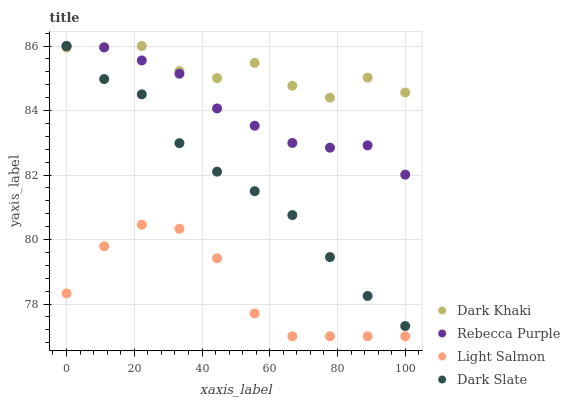Does Light Salmon have the minimum area under the curve?
Answer yes or no. Yes. Does Dark Khaki have the maximum area under the curve?
Answer yes or no. Yes. Does Dark Slate have the minimum area under the curve?
Answer yes or no. No. Does Dark Slate have the maximum area under the curve?
Answer yes or no. No. Is Rebecca Purple the smoothest?
Answer yes or no. Yes. Is Dark Khaki the roughest?
Answer yes or no. Yes. Is Dark Slate the smoothest?
Answer yes or no. No. Is Dark Slate the roughest?
Answer yes or no. No. Does Light Salmon have the lowest value?
Answer yes or no. Yes. Does Dark Slate have the lowest value?
Answer yes or no. No. Does Rebecca Purple have the highest value?
Answer yes or no. Yes. Does Light Salmon have the highest value?
Answer yes or no. No. Is Light Salmon less than Dark Khaki?
Answer yes or no. Yes. Is Dark Slate greater than Light Salmon?
Answer yes or no. Yes. Does Rebecca Purple intersect Dark Khaki?
Answer yes or no. Yes. Is Rebecca Purple less than Dark Khaki?
Answer yes or no. No. Is Rebecca Purple greater than Dark Khaki?
Answer yes or no. No. Does Light Salmon intersect Dark Khaki?
Answer yes or no. No. 